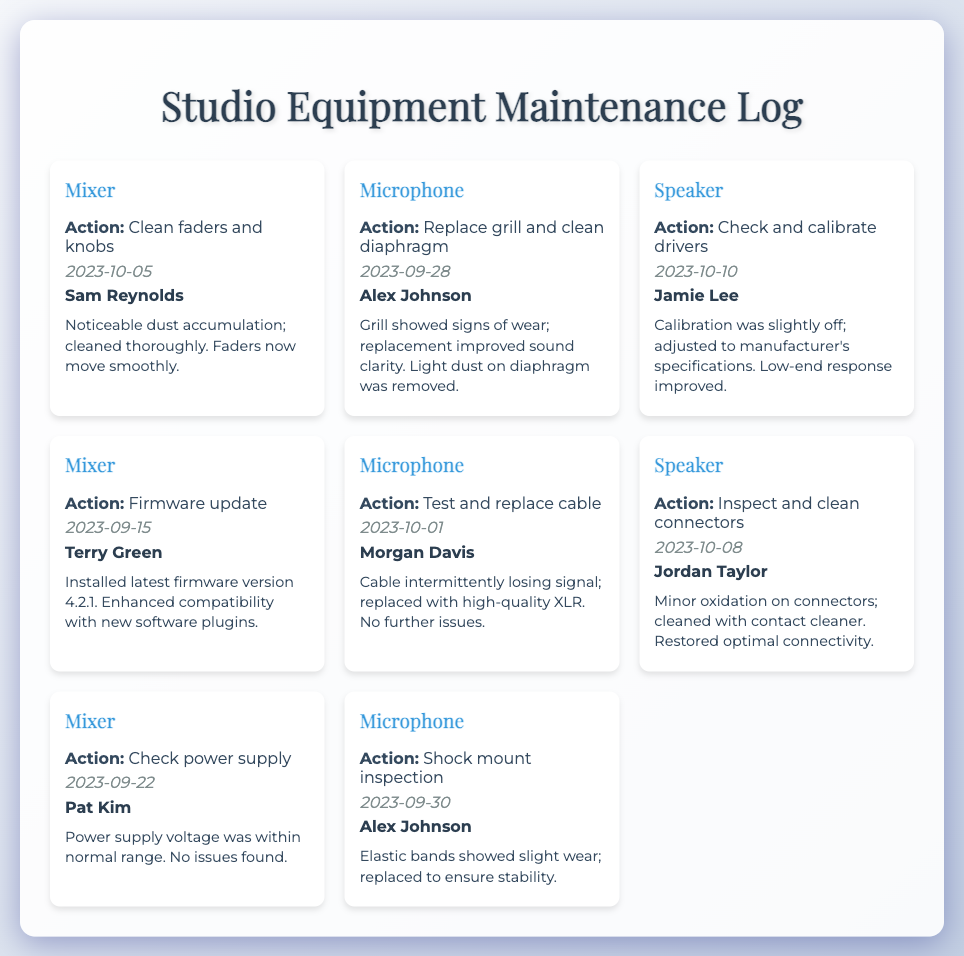What type of action was performed on the Mixer on 2023-10-05? The action taken on the Mixer was cleaning faders and knobs.
Answer: Clean faders and knobs Who was the technician that replaced the grill on the Microphone? The technician involved in replacing the grill was Alex Johnson.
Answer: Alex Johnson What issue was noted during the inspection of the Speaker on 2023-10-08? The issue noted was minor oxidation on connectors.
Answer: Minor oxidation on connectors What date was the firmware update for the Mixer performed? The firmware update for the Mixer was performed on September 15, 2023.
Answer: 2023-09-15 How many entries are listed for Microphone maintenance? There are four entries listed for Microphone maintenance.
Answer: Four What enhancement was noted after calibrating the Speaker drivers? The enhancement noted was improved low-end response.
Answer: Low-end response improved What maintenance action was taken on the Microphone on 2023-09-30? The action taken was a shock mount inspection.
Answer: Shock mount inspection Who conducted the check on the Mixer’s power supply? The technician who conducted the check was Pat Kim.
Answer: Pat Kim 